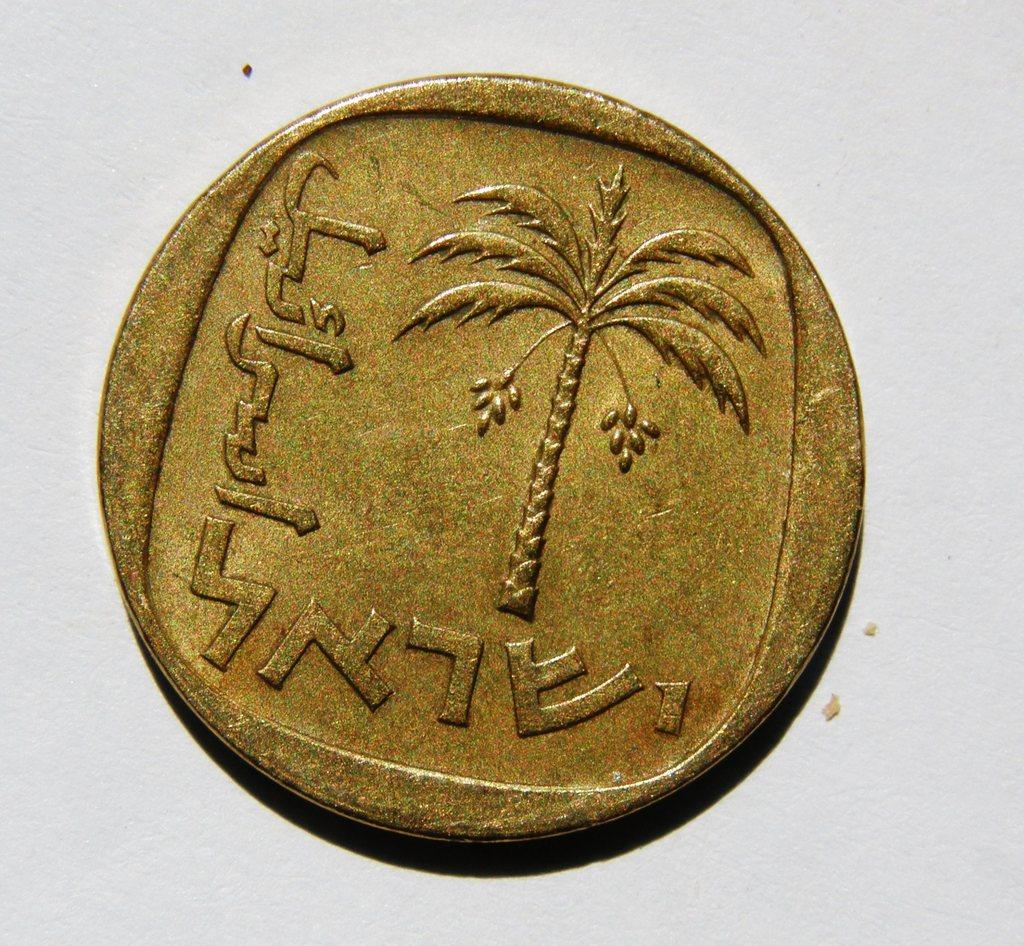Provide a one-sentence caption for the provided image. A gold piece featuring a palm tree and some foreign text along the left and bottom. 